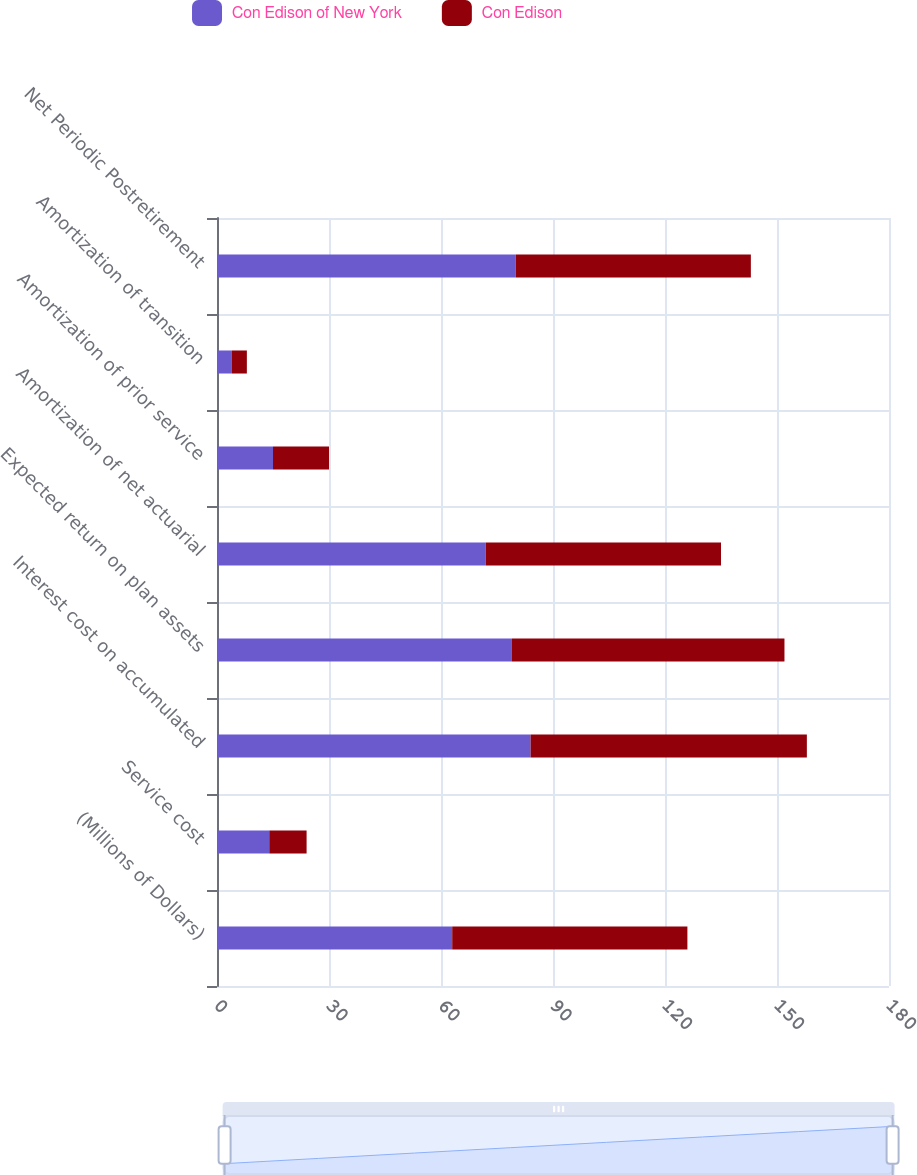Convert chart to OTSL. <chart><loc_0><loc_0><loc_500><loc_500><stacked_bar_chart><ecel><fcel>(Millions of Dollars)<fcel>Service cost<fcel>Interest cost on accumulated<fcel>Expected return on plan assets<fcel>Amortization of net actuarial<fcel>Amortization of prior service<fcel>Amortization of transition<fcel>Net Periodic Postretirement<nl><fcel>Con Edison of New York<fcel>63<fcel>14<fcel>84<fcel>79<fcel>72<fcel>15<fcel>4<fcel>80<nl><fcel>Con Edison<fcel>63<fcel>10<fcel>74<fcel>73<fcel>63<fcel>15<fcel>4<fcel>63<nl></chart> 